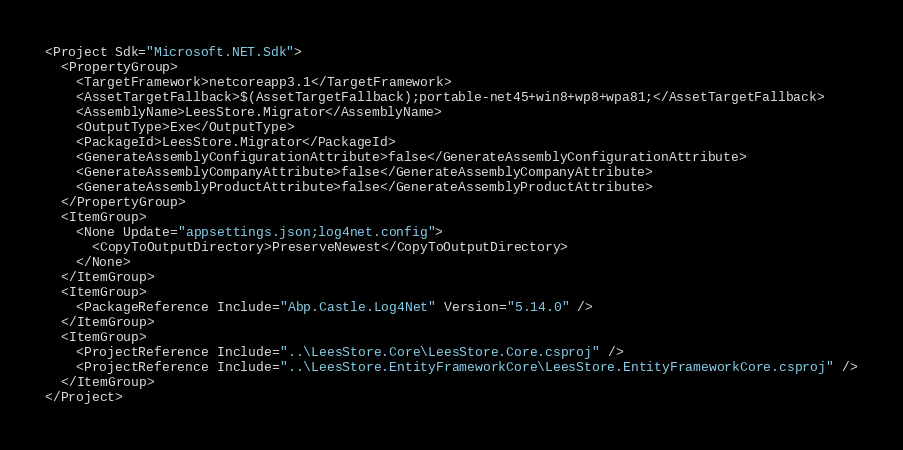<code> <loc_0><loc_0><loc_500><loc_500><_XML_><Project Sdk="Microsoft.NET.Sdk">
  <PropertyGroup>
    <TargetFramework>netcoreapp3.1</TargetFramework>
    <AssetTargetFallback>$(AssetTargetFallback);portable-net45+win8+wp8+wpa81;</AssetTargetFallback>
    <AssemblyName>LeesStore.Migrator</AssemblyName>
    <OutputType>Exe</OutputType>
    <PackageId>LeesStore.Migrator</PackageId>
    <GenerateAssemblyConfigurationAttribute>false</GenerateAssemblyConfigurationAttribute>
    <GenerateAssemblyCompanyAttribute>false</GenerateAssemblyCompanyAttribute>
    <GenerateAssemblyProductAttribute>false</GenerateAssemblyProductAttribute>
  </PropertyGroup>
  <ItemGroup>
    <None Update="appsettings.json;log4net.config">
      <CopyToOutputDirectory>PreserveNewest</CopyToOutputDirectory>
    </None>
  </ItemGroup>
  <ItemGroup>
    <PackageReference Include="Abp.Castle.Log4Net" Version="5.14.0" />
  </ItemGroup>
  <ItemGroup>
    <ProjectReference Include="..\LeesStore.Core\LeesStore.Core.csproj" />
    <ProjectReference Include="..\LeesStore.EntityFrameworkCore\LeesStore.EntityFrameworkCore.csproj" />
  </ItemGroup>
</Project></code> 